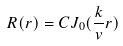<formula> <loc_0><loc_0><loc_500><loc_500>R ( r ) = C J _ { 0 } ( \frac { k } { v } r )</formula> 